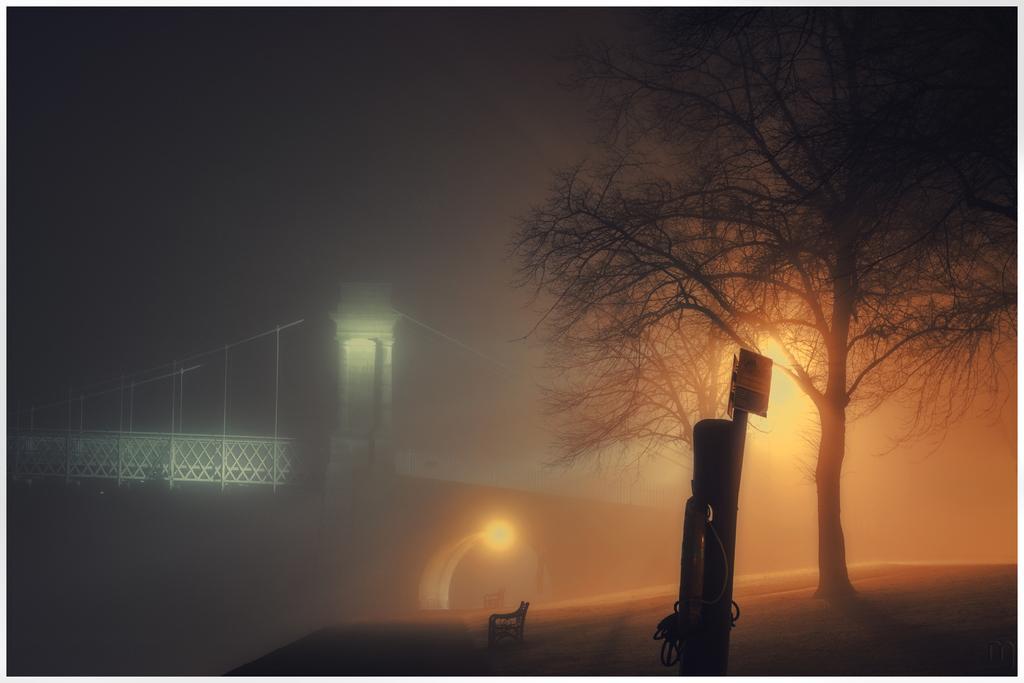How would you summarize this image in a sentence or two? In this image I can see a bench, a tree, few boards, few lights and in background I can see a bridge. I can also see this image is little bit in dark. 